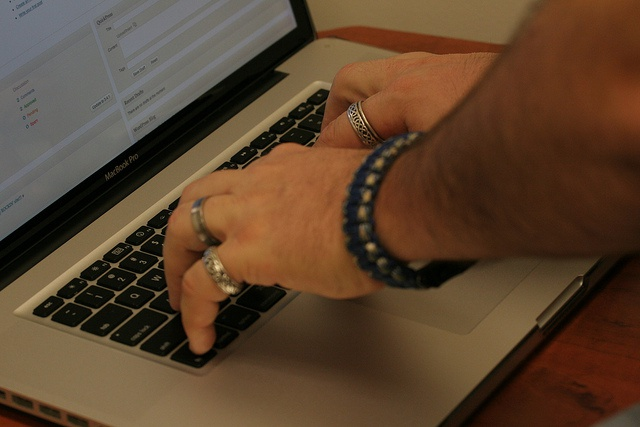Describe the objects in this image and their specific colors. I can see laptop in gray, black, and maroon tones, people in gray, maroon, brown, and black tones, and keyboard in gray, black, tan, and olive tones in this image. 